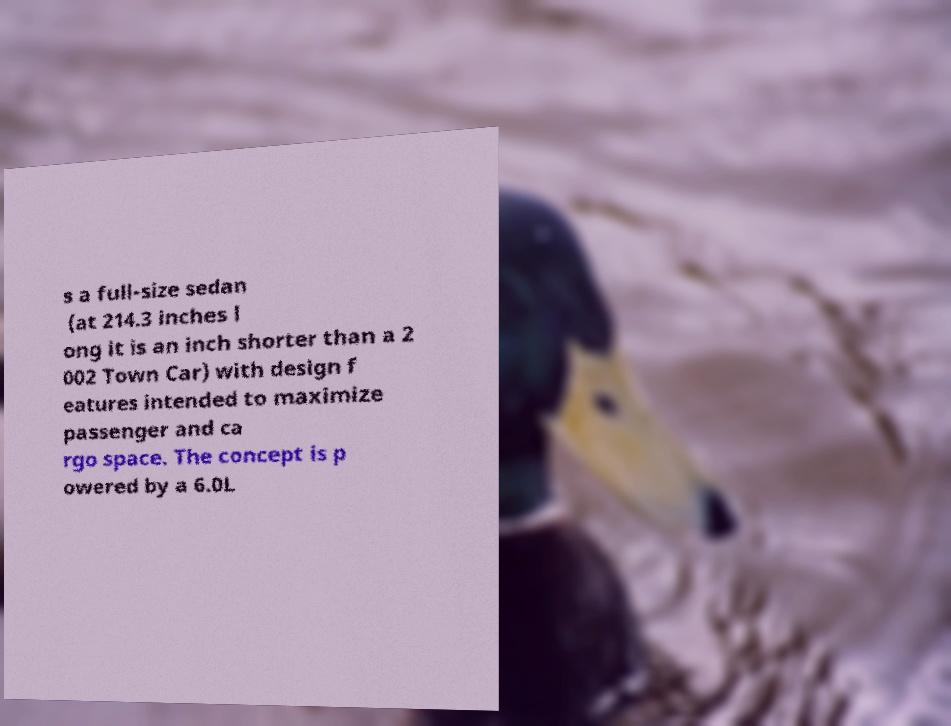There's text embedded in this image that I need extracted. Can you transcribe it verbatim? s a full-size sedan (at 214.3 inches l ong it is an inch shorter than a 2 002 Town Car) with design f eatures intended to maximize passenger and ca rgo space. The concept is p owered by a 6.0L 